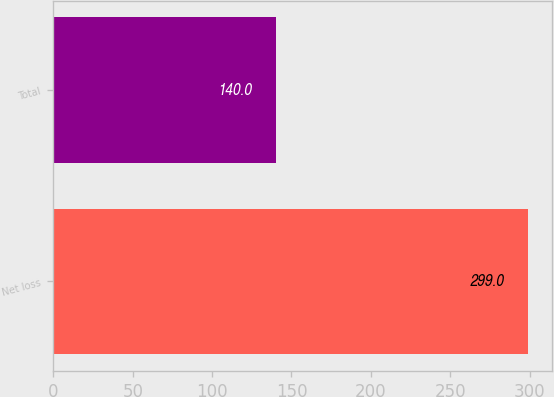Convert chart. <chart><loc_0><loc_0><loc_500><loc_500><bar_chart><fcel>Net loss<fcel>Total<nl><fcel>299<fcel>140<nl></chart> 